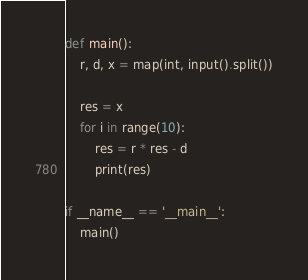Convert code to text. <code><loc_0><loc_0><loc_500><loc_500><_Python_>def main():
    r, d, x = map(int, input().split())

    res = x
    for i in range(10):
        res = r * res - d
        print(res) 

if __name__ == '__main__':
    main()</code> 